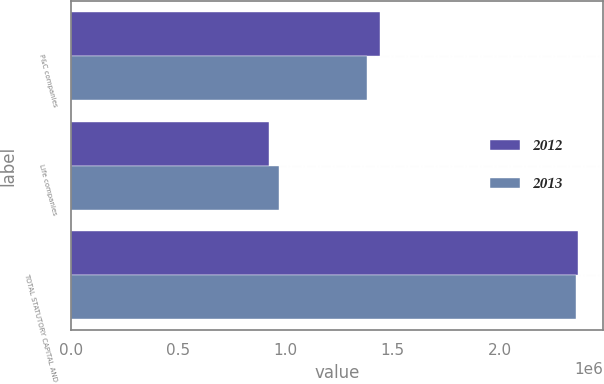Convert chart. <chart><loc_0><loc_0><loc_500><loc_500><stacked_bar_chart><ecel><fcel>P&C companies<fcel>Life companies<fcel>TOTAL STATUTORY CAPITAL AND<nl><fcel>2012<fcel>1.44039e+06<fcel>923660<fcel>2.36405e+06<nl><fcel>2013<fcel>1.38274e+06<fcel>973446<fcel>2.35619e+06<nl></chart> 